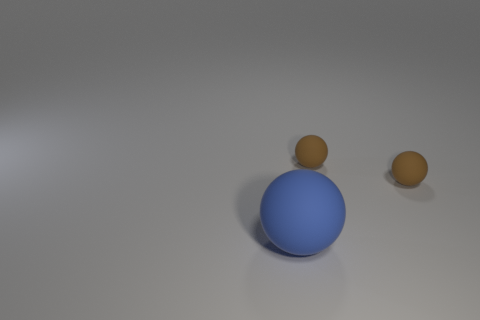Can you describe the lighting and shadow effect seen in the image? The image exhibits a single light source casting diffuse shadows that extend toward the bottom right. The shadows are soft-edged, suggesting a not very intense light source and contributing to the image's three-dimensional appearance. How does the lighting affect the appearance of the spheres? The light source accentuates the glossy texture of the large blue sphere, causing it to reflect light strongly and appear shiny. The matte texture of the small brown spheres results in a more subdued appearance, as they absorb more of the light and reflect less, creating a stark contrast between the surfaces. 